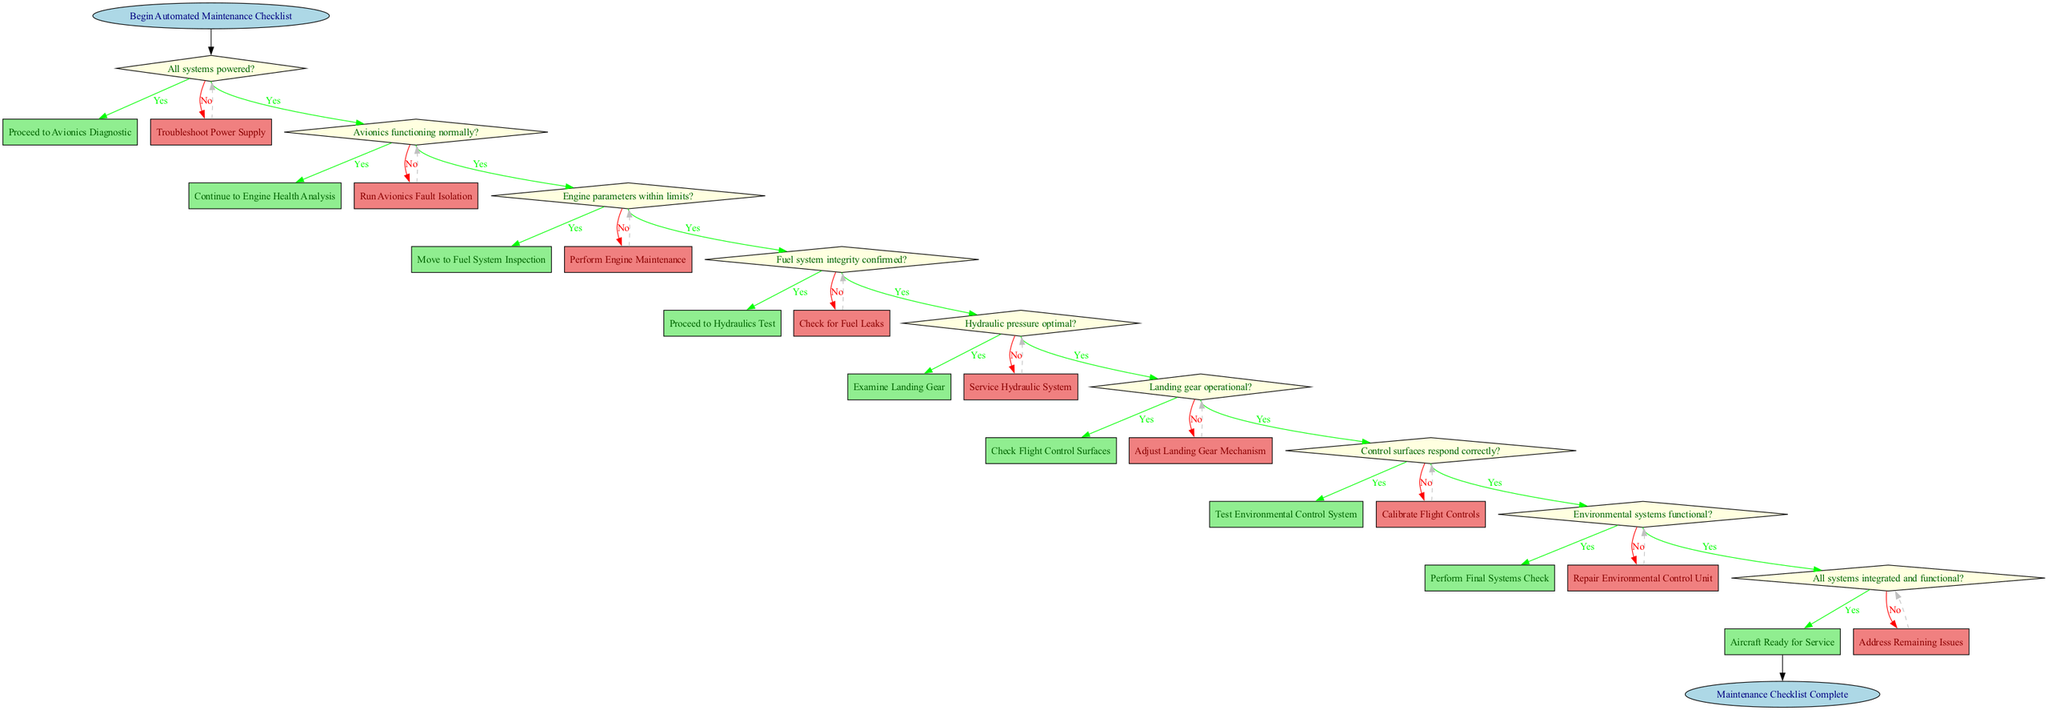What is the first step in the checklist? The diagram starts at the "Begin Automated Maintenance Checklist" node, indicating this is the first action to be taken in the flow.
Answer: Begin Automated Maintenance Checklist How many decision points are there in total? The diagram includes decision points for each of the system checks, totaling to nine decision questions based on the structure of the checklist.
Answer: 9 What action follows a "no" response for the "Engine parameters within limits?" A "no" response to that decision directs to "Perform Engine Maintenance," which indicates the necessary corrective action based on engine performance issues.
Answer: Perform Engine Maintenance Which node leads to the "Final Systems Integration Check"? The node that leads to the "Final Systems Integration Check" is "Environmental Control System Test," which occurs after confirming functionality of the environmental systems.
Answer: Environmental Control System Test What happens if the hydraulic pressure is not optimal? If the hydraulic pressure is not optimal, the flow indicates to "Service Hydraulic System," indicating immediate attention to rectify hydraulic issues.
Answer: Service Hydraulic System What is the outcome if all systems integrated and functional? The last decision check leads to "Aircraft Ready for Service" if all systems check out correctly, indicating the aircraft is cleared for operation.
Answer: Aircraft Ready for Service If the landing gear is operational, what is the next step? If the landing gear check confirms operation, the next step indicated is to "Check Flight Control Surfaces," continuing the maintenance process.
Answer: Check Flight Control Surfaces What does a "no" response to the "Environmental systems functional?" decision lead to? A "no" response to this decision leads to an action of "Repair Environmental Control Unit," which highlights the need for repairs if the system isn't functioning.
Answer: Repair Environmental Control Unit 